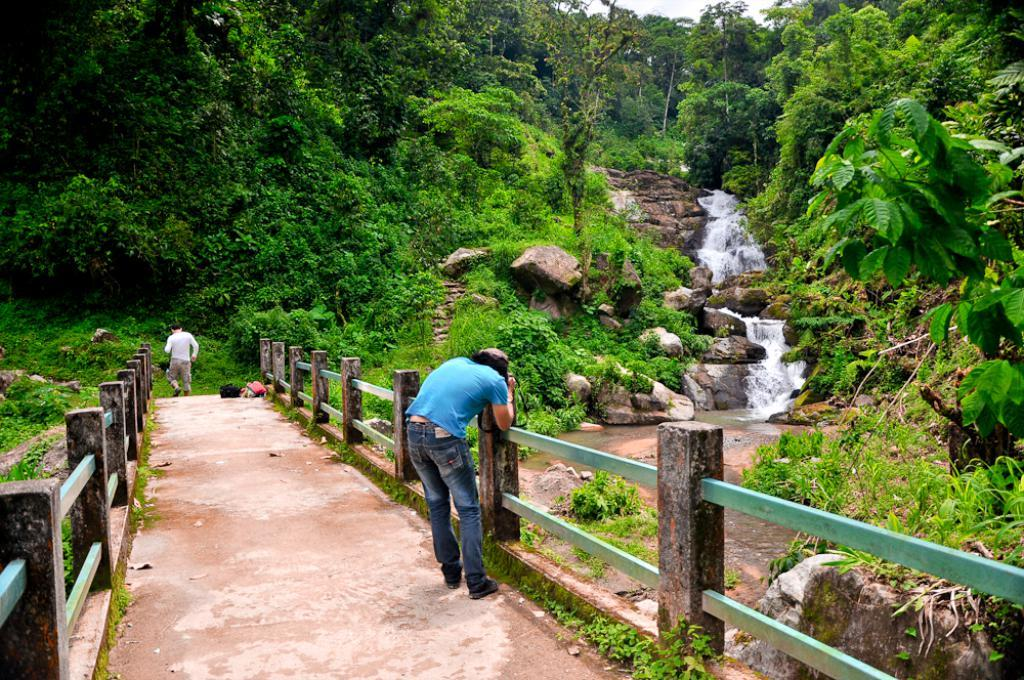How many people are in the image? There are two persons in the image. What is one person doing with an object? One person is holding an object. What type of natural environment can be seen in the image? There are trees, plants, water, grass, and the sky visible in the image. What man-made structures are present in the image? There is a fence in the image. What is the texture of the stone in the image? The stone in the image has a solid, hard texture. What type of vacation is the ladybug enjoying in the image? There is no ladybug present in the image, and therefore no vacation can be observed. Is the person driving a vehicle in the image? There is no vehicle or driving activity present in the image. 